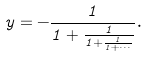Convert formula to latex. <formula><loc_0><loc_0><loc_500><loc_500>y = - \frac { 1 } { 1 + \frac { 1 } { 1 + \frac { 1 } { 1 + \cdot \cdot \cdot } } } .</formula> 